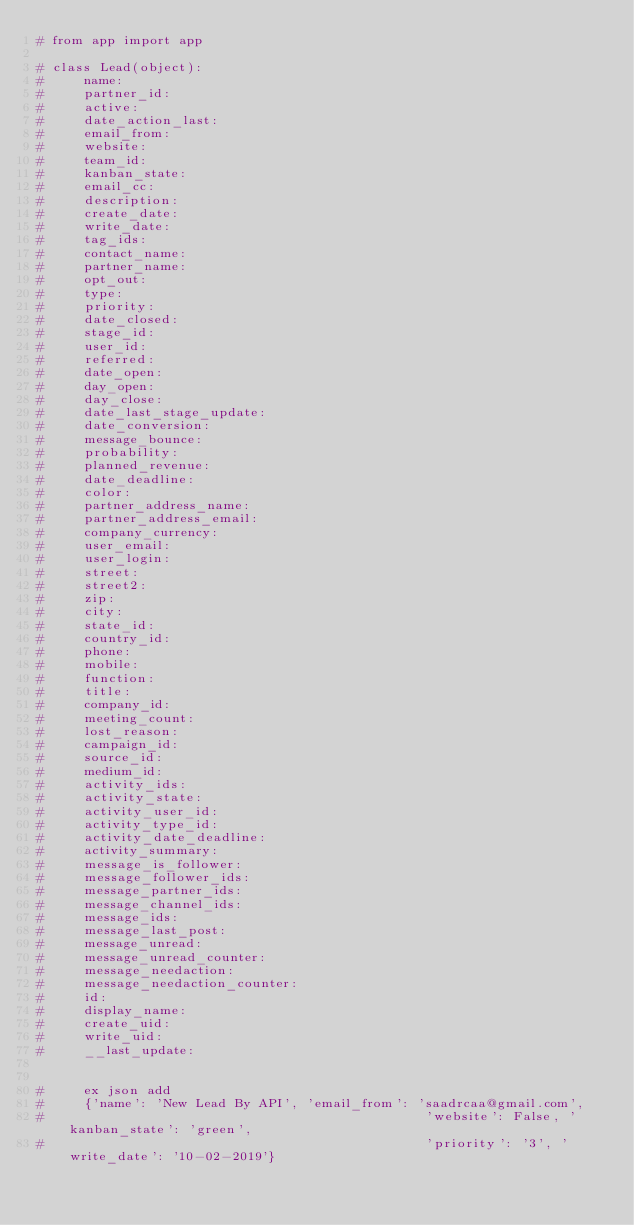<code> <loc_0><loc_0><loc_500><loc_500><_Python_># from app import app

# class Lead(object):
#     name:
#     partner_id:
#     active:
#     date_action_last:
#     email_from:
#     website:
#     team_id:
#     kanban_state:
#     email_cc:
#     description:
#     create_date:
#     write_date:
#     tag_ids:
#     contact_name:
#     partner_name:
#     opt_out:
#     type:
#     priority:
#     date_closed:
#     stage_id:
#     user_id:
#     referred:
#     date_open:
#     day_open:
#     day_close:
#     date_last_stage_update:
#     date_conversion:
#     message_bounce:
#     probability:
#     planned_revenue:
#     date_deadline:
#     color:
#     partner_address_name:
#     partner_address_email:
#     company_currency:
#     user_email:
#     user_login:
#     street:
#     street2:
#     zip:
#     city:
#     state_id:
#     country_id:
#     phone:
#     mobile:
#     function:
#     title:
#     company_id:
#     meeting_count:
#     lost_reason:
#     campaign_id:
#     source_id:
#     medium_id:
#     activity_ids:
#     activity_state:
#     activity_user_id:
#     activity_type_id:
#     activity_date_deadline:
#     activity_summary:
#     message_is_follower:
#     message_follower_ids:
#     message_partner_ids:
#     message_channel_ids:
#     message_ids:
#     message_last_post:
#     message_unread:
#     message_unread_counter:
#     message_needaction:
#     message_needaction_counter:
#     id:
#     display_name:
#     create_uid:
#     write_uid:
#     __last_update:
    

#     ex json add
#     {'name': 'New Lead By API', 'email_from': 'saadrcaa@gmail.com',
#                                                'website': False, 'kanban_state': 'green',
#                                                'priority': '3', 'write_date': '10-02-2019'}</code> 